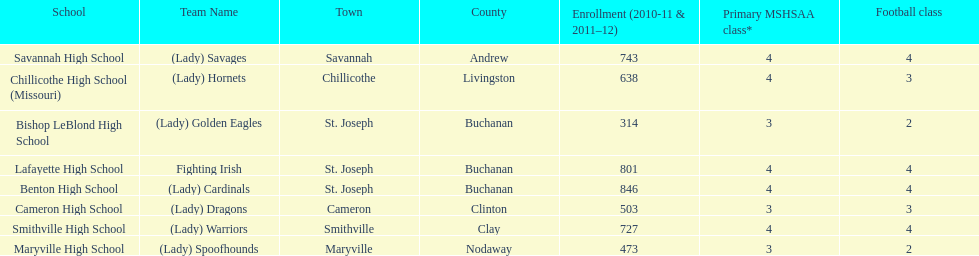How many teams are named after birds? 2. Could you help me parse every detail presented in this table? {'header': ['School', 'Team Name', 'Town', 'County', 'Enrollment (2010-11 & 2011–12)', 'Primary MSHSAA class*', 'Football class'], 'rows': [['Savannah High School', '(Lady) Savages', 'Savannah', 'Andrew', '743', '4', '4'], ['Chillicothe High School (Missouri)', '(Lady) Hornets', 'Chillicothe', 'Livingston', '638', '4', '3'], ['Bishop LeBlond High School', '(Lady) Golden Eagles', 'St. Joseph', 'Buchanan', '314', '3', '2'], ['Lafayette High School', 'Fighting Irish', 'St. Joseph', 'Buchanan', '801', '4', '4'], ['Benton High School', '(Lady) Cardinals', 'St. Joseph', 'Buchanan', '846', '4', '4'], ['Cameron High School', '(Lady) Dragons', 'Cameron', 'Clinton', '503', '3', '3'], ['Smithville High School', '(Lady) Warriors', 'Smithville', 'Clay', '727', '4', '4'], ['Maryville High School', '(Lady) Spoofhounds', 'Maryville', 'Nodaway', '473', '3', '2']]} 